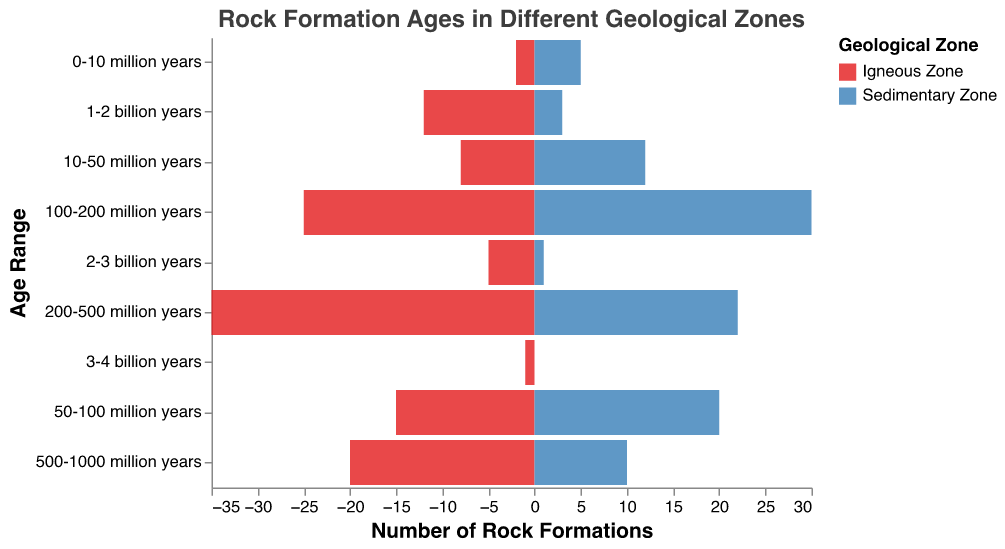What are the colors used for the Igneous Zone and the Sedimentary Zone? The Igneous Zone is represented by a shade of red while the Sedimentary Zone is in a shade of blue.
Answer: Red for Igneous, Blue for Sedimentary What is the title of the figure? The title is indicated at the top of the figure. It reads "Rock Formation Ages in Different Geological Zones".
Answer: Rock Formation Ages in Different Geological Zones Which age range shows the highest number of rock formations in the Igneous Zone? By looking at the bar lengths for the Igneous Zone, the age range "200-500 million years" has the longest bar.
Answer: 200-500 million years Which age range has the lowest number of rock formations in the Sedimentary Zone? The age range "3-4 billion years" has the shortest bar (zero length) in the Sedimentary Zone.
Answer: 3-4 billion years How many rock formations are in the Igneous Zone for the age range "1-2 billion years"? The bar for the Igneous Zone in the "1-2 billion years" range extends to 12.
Answer: 12 What is the total number of rock formations in the Igneous Zone for age ranges less than 100 million years? Add the values for "0-10 million years", "10-50 million years", and "50-100 million years": 2 + 8 + 15 = 25.
Answer: 25 Which zone has more rock formations in the age range "500-1000 million years"? Compare the bar lengths for both zones. The Igneous Zone has 20 while the Sedimentary Zone has 10.
Answer: Igneous Zone Between the age ranges "200-500 million years" and "500-1000 million years", which range shows a larger number of rock formations in both zones combined? Sum each range for both zones: (35 (Igneous) + 22 (Sedimentary) = 57) for "200-500 million years" and (20 (Igneous) + 10 (Sedimentary) = 30) for "500-1000 million years".
Answer: 200-500 million years How does the trend in the number of rock formations change from the younger to older age ranges in the Sedimentary Zone? Look at the changes in bar lengths moving from "0-10 million years" to "3-4 billion years" in the Sedimentary Zone. It starts at 5 and decreases, nearly reaching zero as age increases.
Answer: Decrease In which geological zone do the rock formations reach a peak value, and what is that peak? The highest bar value in the figure is for the Igneous Zone within the "200-500 million years" age range, which reaches 35.
Answer: Igneous Zone, 35 